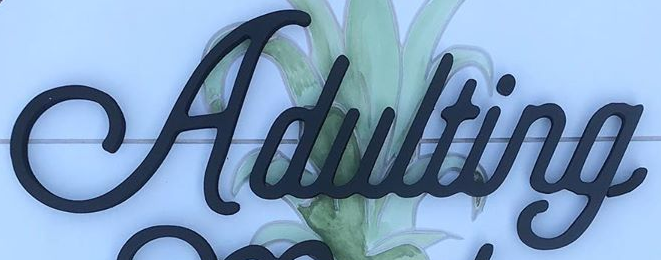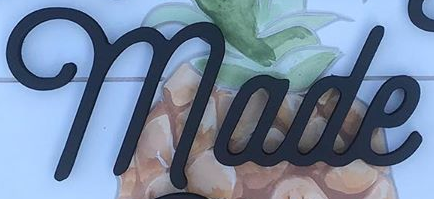What words are shown in these images in order, separated by a semicolon? Adulting; made 